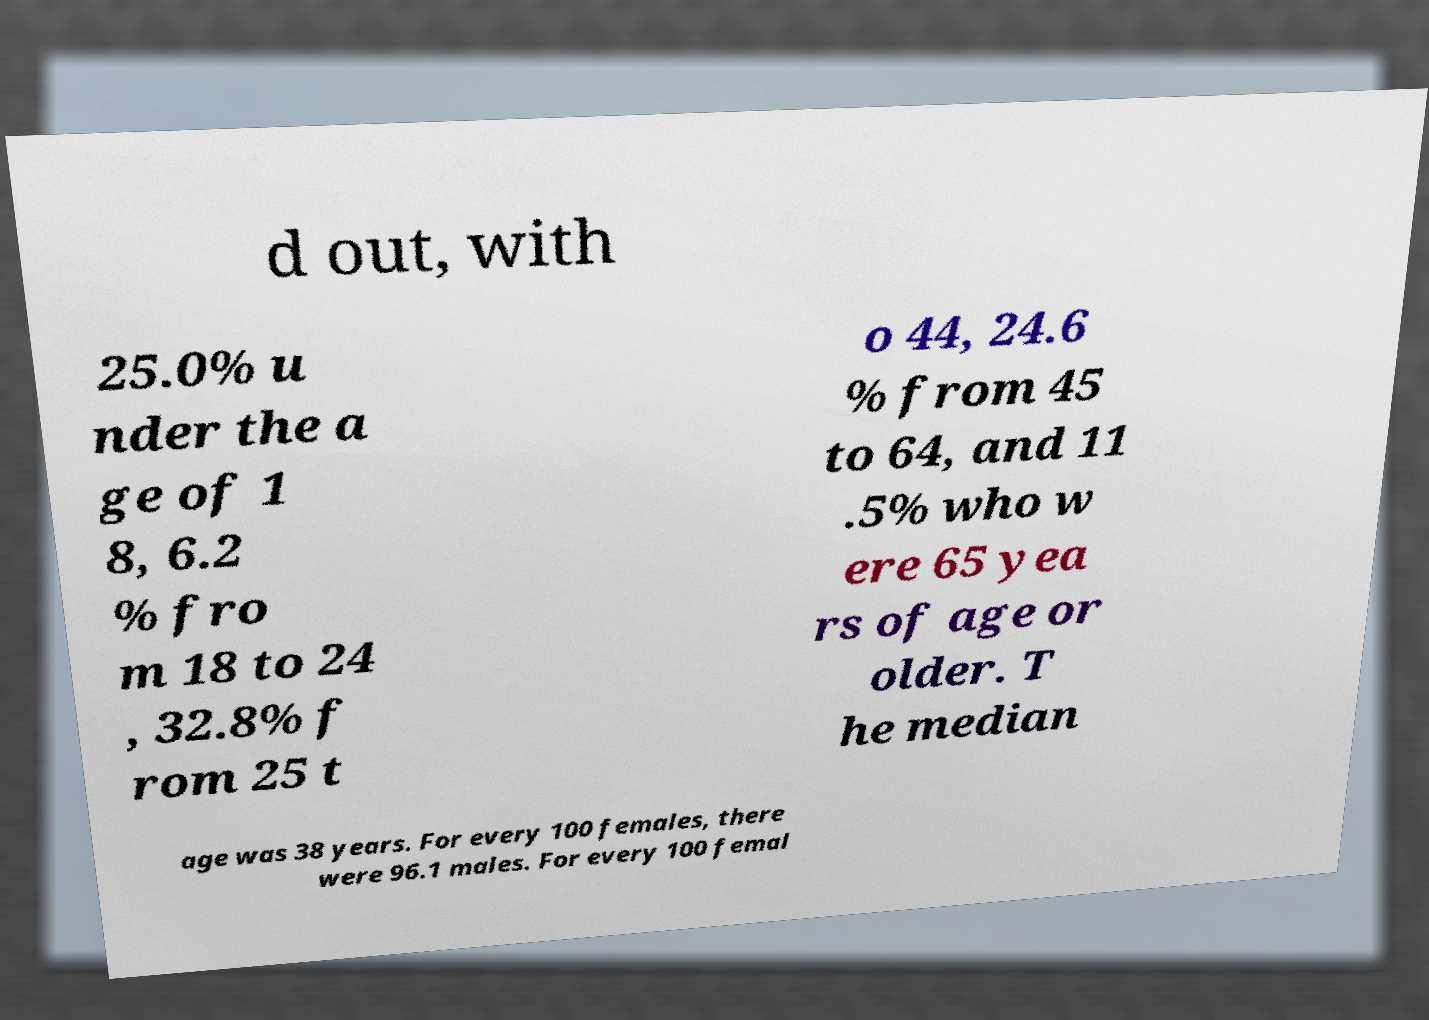Could you extract and type out the text from this image? d out, with 25.0% u nder the a ge of 1 8, 6.2 % fro m 18 to 24 , 32.8% f rom 25 t o 44, 24.6 % from 45 to 64, and 11 .5% who w ere 65 yea rs of age or older. T he median age was 38 years. For every 100 females, there were 96.1 males. For every 100 femal 